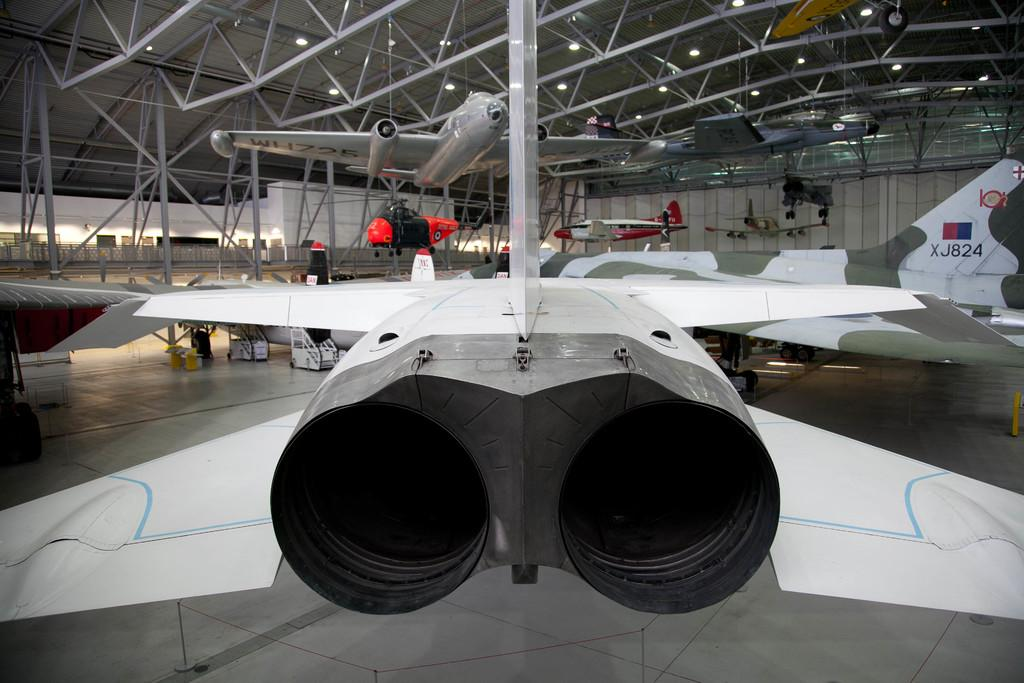Provide a one-sentence caption for the provided image. Various military airplanes are on display in a hanger, including one with call letters XJ824.one. 